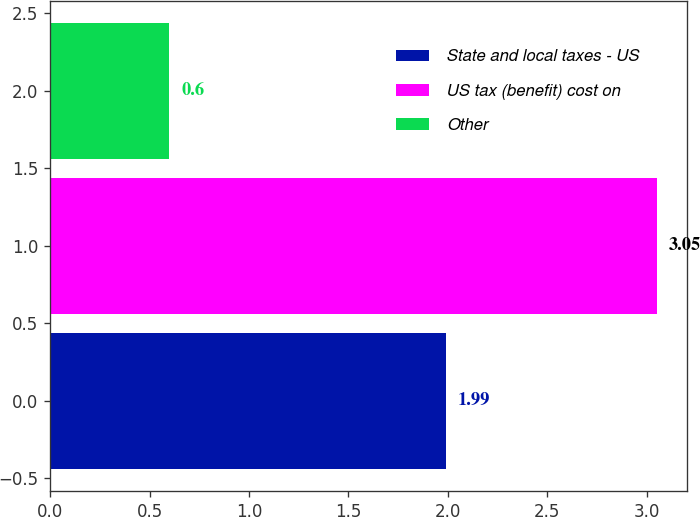Convert chart to OTSL. <chart><loc_0><loc_0><loc_500><loc_500><bar_chart><fcel>State and local taxes - US<fcel>US tax (benefit) cost on<fcel>Other<nl><fcel>1.99<fcel>3.05<fcel>0.6<nl></chart> 